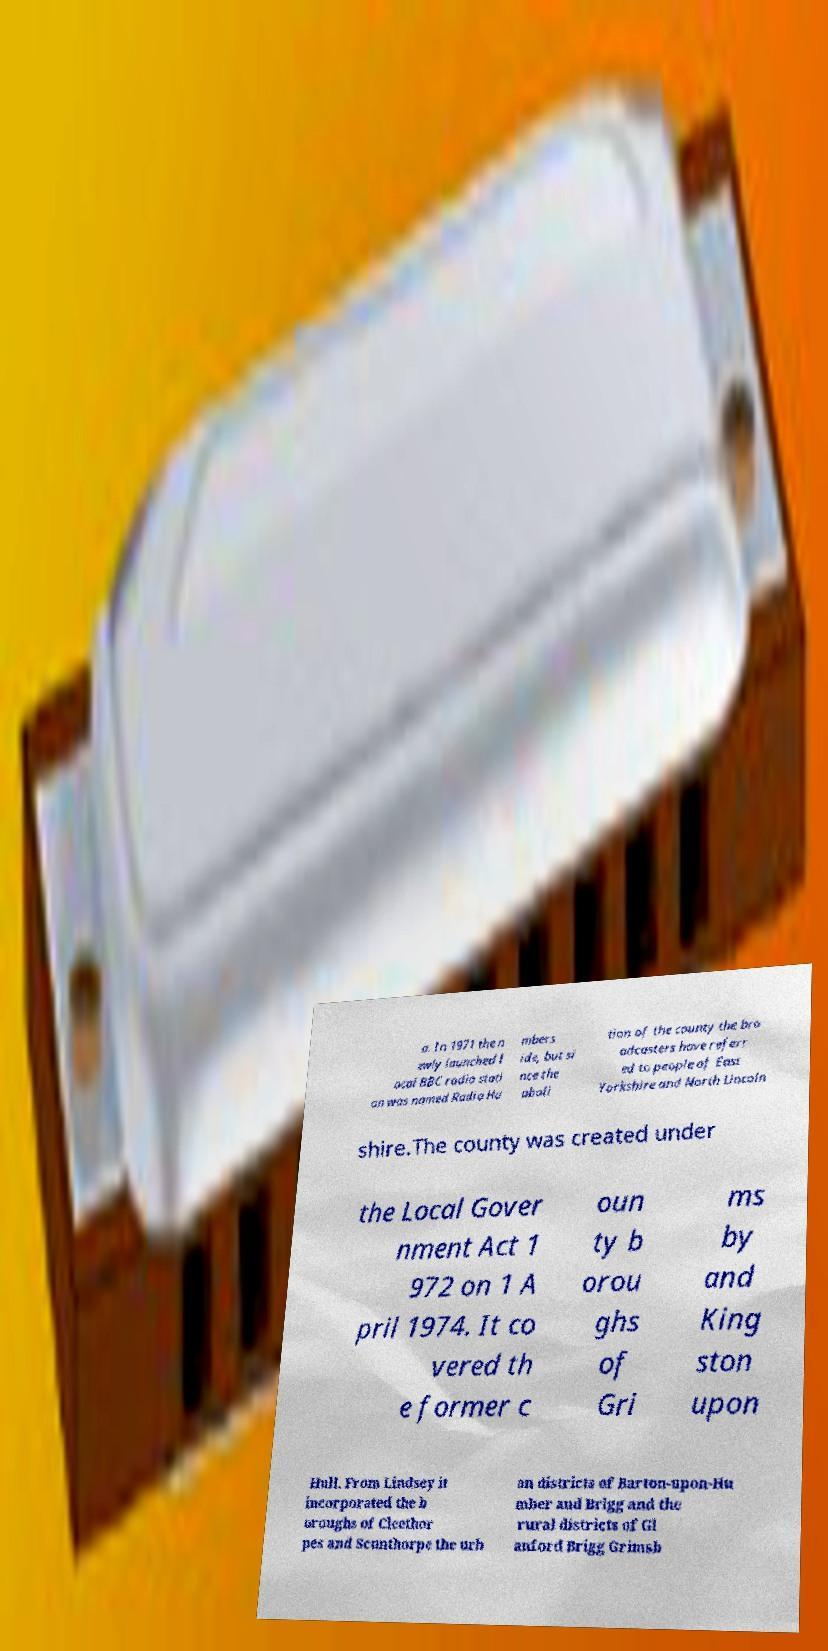Can you accurately transcribe the text from the provided image for me? a. In 1971 the n ewly launched l ocal BBC radio stati on was named Radio Hu mbers ide, but si nce the aboli tion of the county the bro adcasters have referr ed to people of East Yorkshire and North Lincoln shire.The county was created under the Local Gover nment Act 1 972 on 1 A pril 1974. It co vered th e former c oun ty b orou ghs of Gri ms by and King ston upon Hull. From Lindsey it incorporated the b oroughs of Cleethor pes and Scunthorpe the urb an districts of Barton-upon-Hu mber and Brigg and the rural districts of Gl anford Brigg Grimsb 